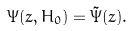<formula> <loc_0><loc_0><loc_500><loc_500>\Psi ( z , H _ { 0 } ) = \tilde { \Psi } ( z ) .</formula> 